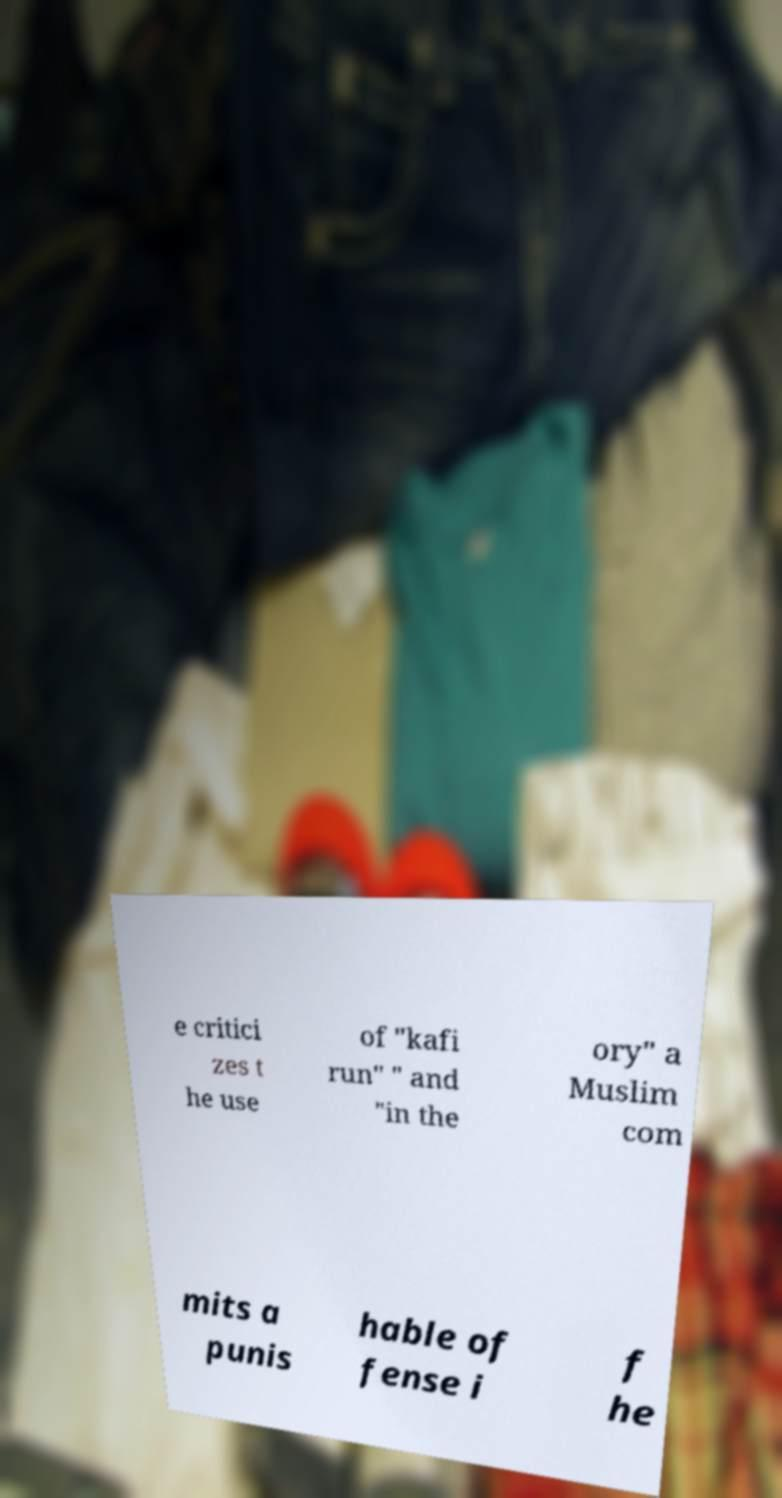Could you assist in decoding the text presented in this image and type it out clearly? e critici zes t he use of "kafi run" " and "in the ory" a Muslim com mits a punis hable of fense i f he 